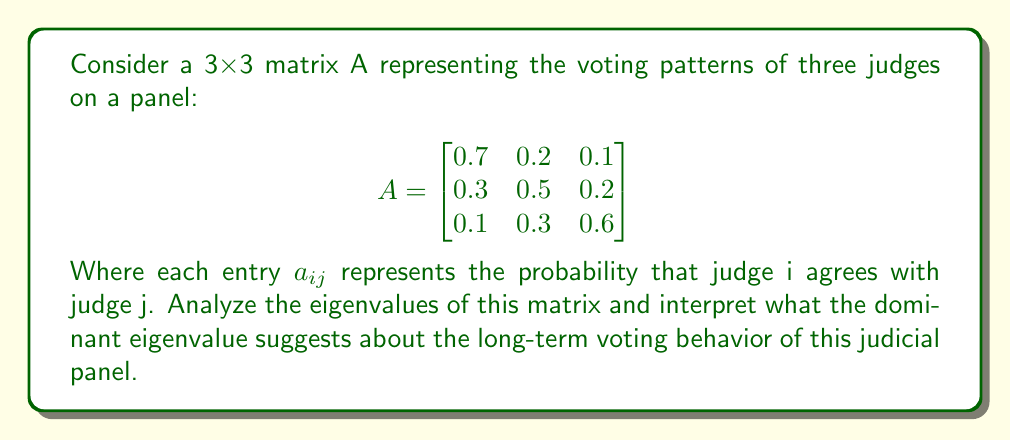Provide a solution to this math problem. 1) To find the eigenvalues, we need to solve the characteristic equation:
   $det(A - \lambda I) = 0$

2) Expanding this determinant:
   $$\begin{vmatrix}
   0.7-\lambda & 0.2 & 0.1 \\
   0.3 & 0.5-\lambda & 0.2 \\
   0.1 & 0.3 & 0.6-\lambda
   \end{vmatrix} = 0$$

3) This gives us the cubic equation:
   $-\lambda^3 + 1.8\lambda^2 - 0.83\lambda + 0.1 = 0$

4) Solving this equation (using a computer algebra system), we get:
   $\lambda_1 \approx 1$
   $\lambda_2 \approx 0.4472$
   $\lambda_3 \approx 0.3528$

5) The dominant eigenvalue is $\lambda_1 \approx 1$. This is expected for a stochastic matrix (where each row sums to 1).

6) The eigenvector $v_1$ corresponding to $\lambda_1$ represents the steady-state distribution of votes. It can be found by solving $(A - I)v_1 = 0$.

7) Interpretation: The dominant eigenvalue being close to 1 suggests that over time, the voting patterns will converge to a stable distribution represented by $v_1$. This distribution would indicate the long-term probability of each judge's opinion being adopted by the panel.

8) The other eigenvalues ($\lambda_2$ and $\lambda_3$) represent transient behaviors that will decay over time, with $\lambda_2$ decaying more slowly than $\lambda_3$.
Answer: $\lambda_1 \approx 1$, $\lambda_2 \approx 0.4472$, $\lambda_3 \approx 0.3528$; dominant eigenvalue ≈ 1 indicates convergence to stable voting distribution. 